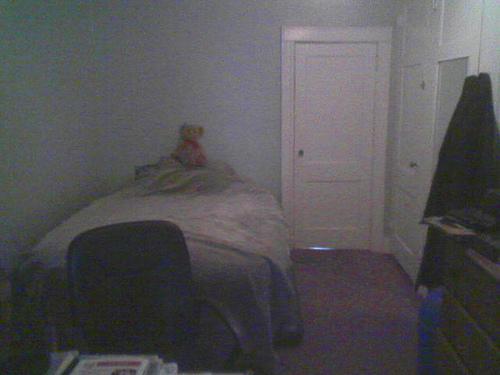How many beds are there?
Give a very brief answer. 1. How many women are hugging the fire hydrant?
Give a very brief answer. 0. 